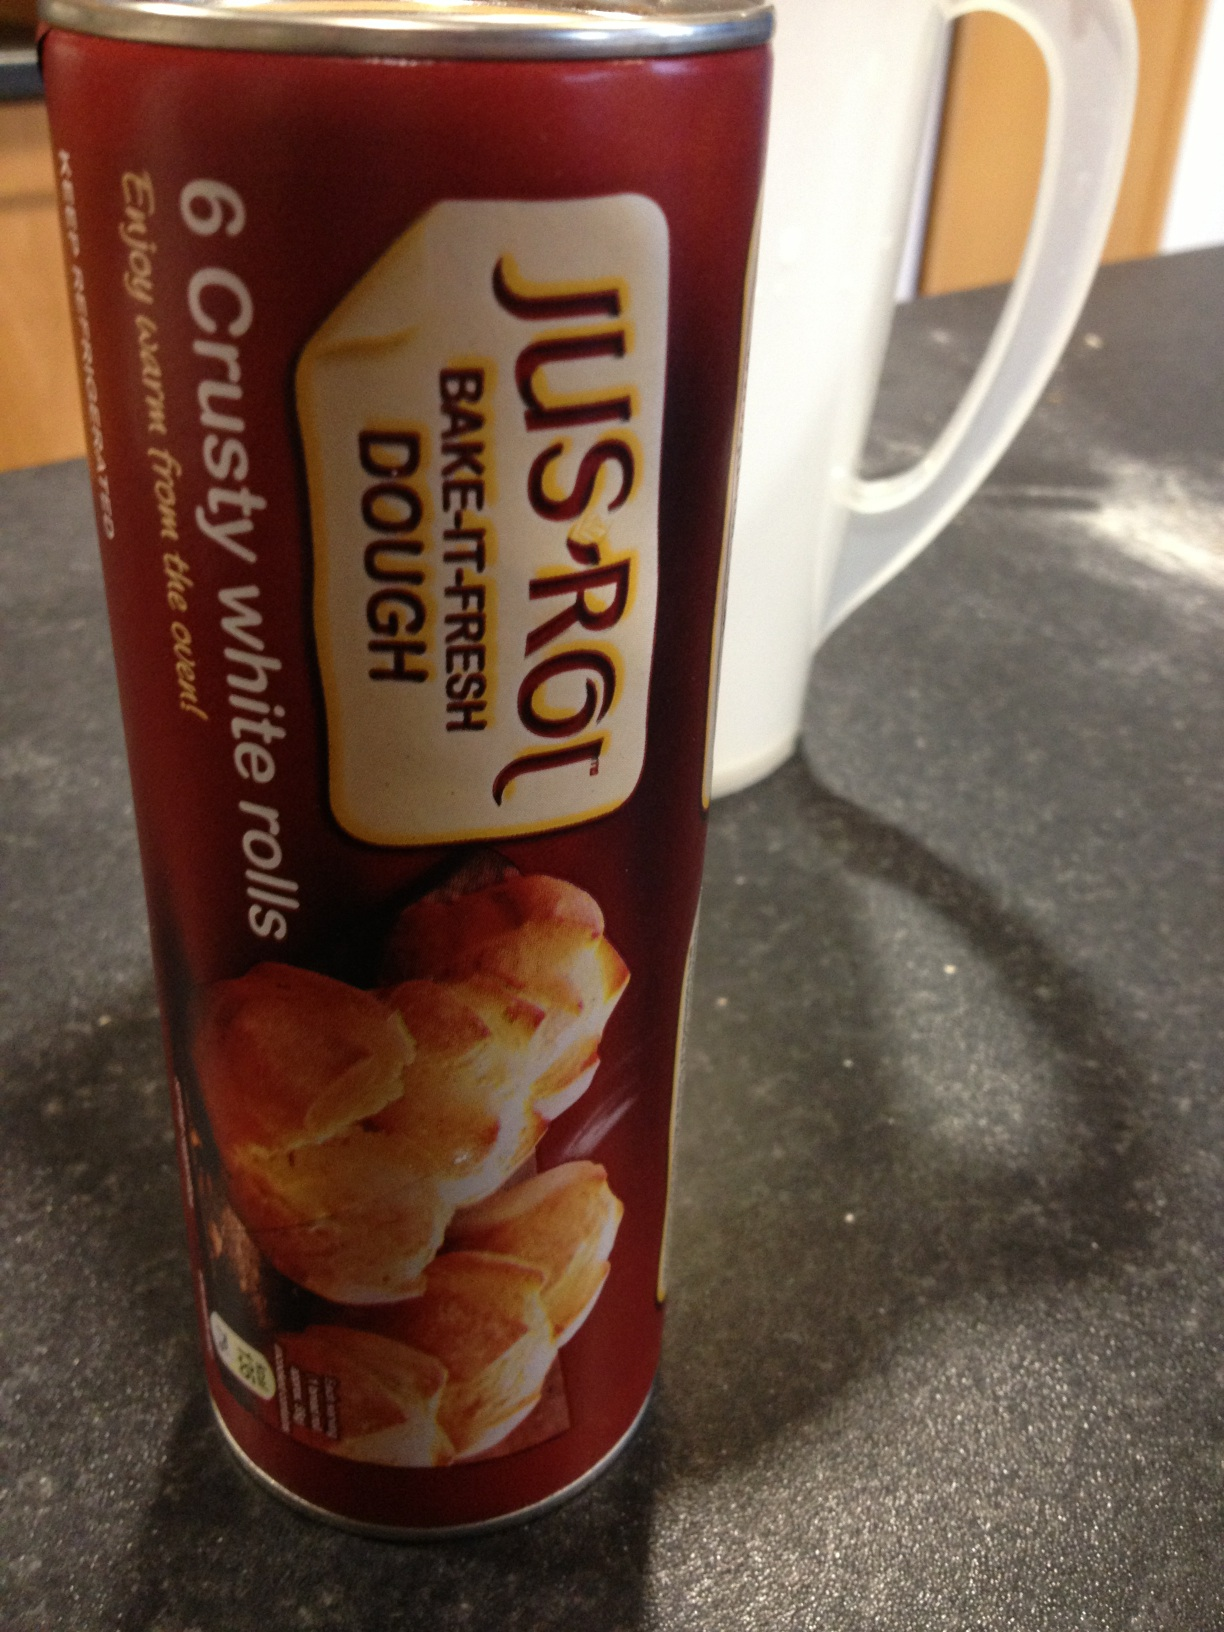What can you tell me about the brand Jus-Rol? Jus-Rol is a well-known brand specializing in ready-to-bake pastry dough. They offer a variety of products that make it easy to bake delicious pastries at home without the hassle of preparing dough from scratch. Their range includes puff pastry, shortcrust pastry, pizza dough, and more. Jus-Rol highlights convenience and quality, allowing customers to create bakery-style items quickly and effortlessly. Can you suggest a creative recipe using the Jus-Rol white rolls dough? Absolutely! Here's a creative recipe for Garlic Herb Pull-Apart Rolls. First, preheat your oven according to the package instructions. Then, unroll the dough and cut it into small squares. Melt some butter and mix in minced garlic and chopped fresh herbs like rosemary, thyme, and parsley. Dip each dough square into the garlic butter mix and arrange them in a greased baking dish so they are touching each other. Bake as per the package instructions until golden brown. Enjoy your aromatic and flavorful pull-apart rolls perfect for any meal! Describe a scenario where these rolls would be a hit at a gathering. Imagine hosting a cozy family brunch on a Sunday morning. The aroma of freshly baked Jus-Rol crusty white rolls fills the kitchen, promising a delightful addition to your table spread. As your guests arrive, they can't resist the smell and are eager to try the warm, crusty rolls. Serve them with an assortment of spreads like homemade jam, creamy butter, and honey, alongside savory options like cheese and sliced meats. These rolls will definitely be a hit, adding that warm, homemade touch that makes everyone feel right at home. 